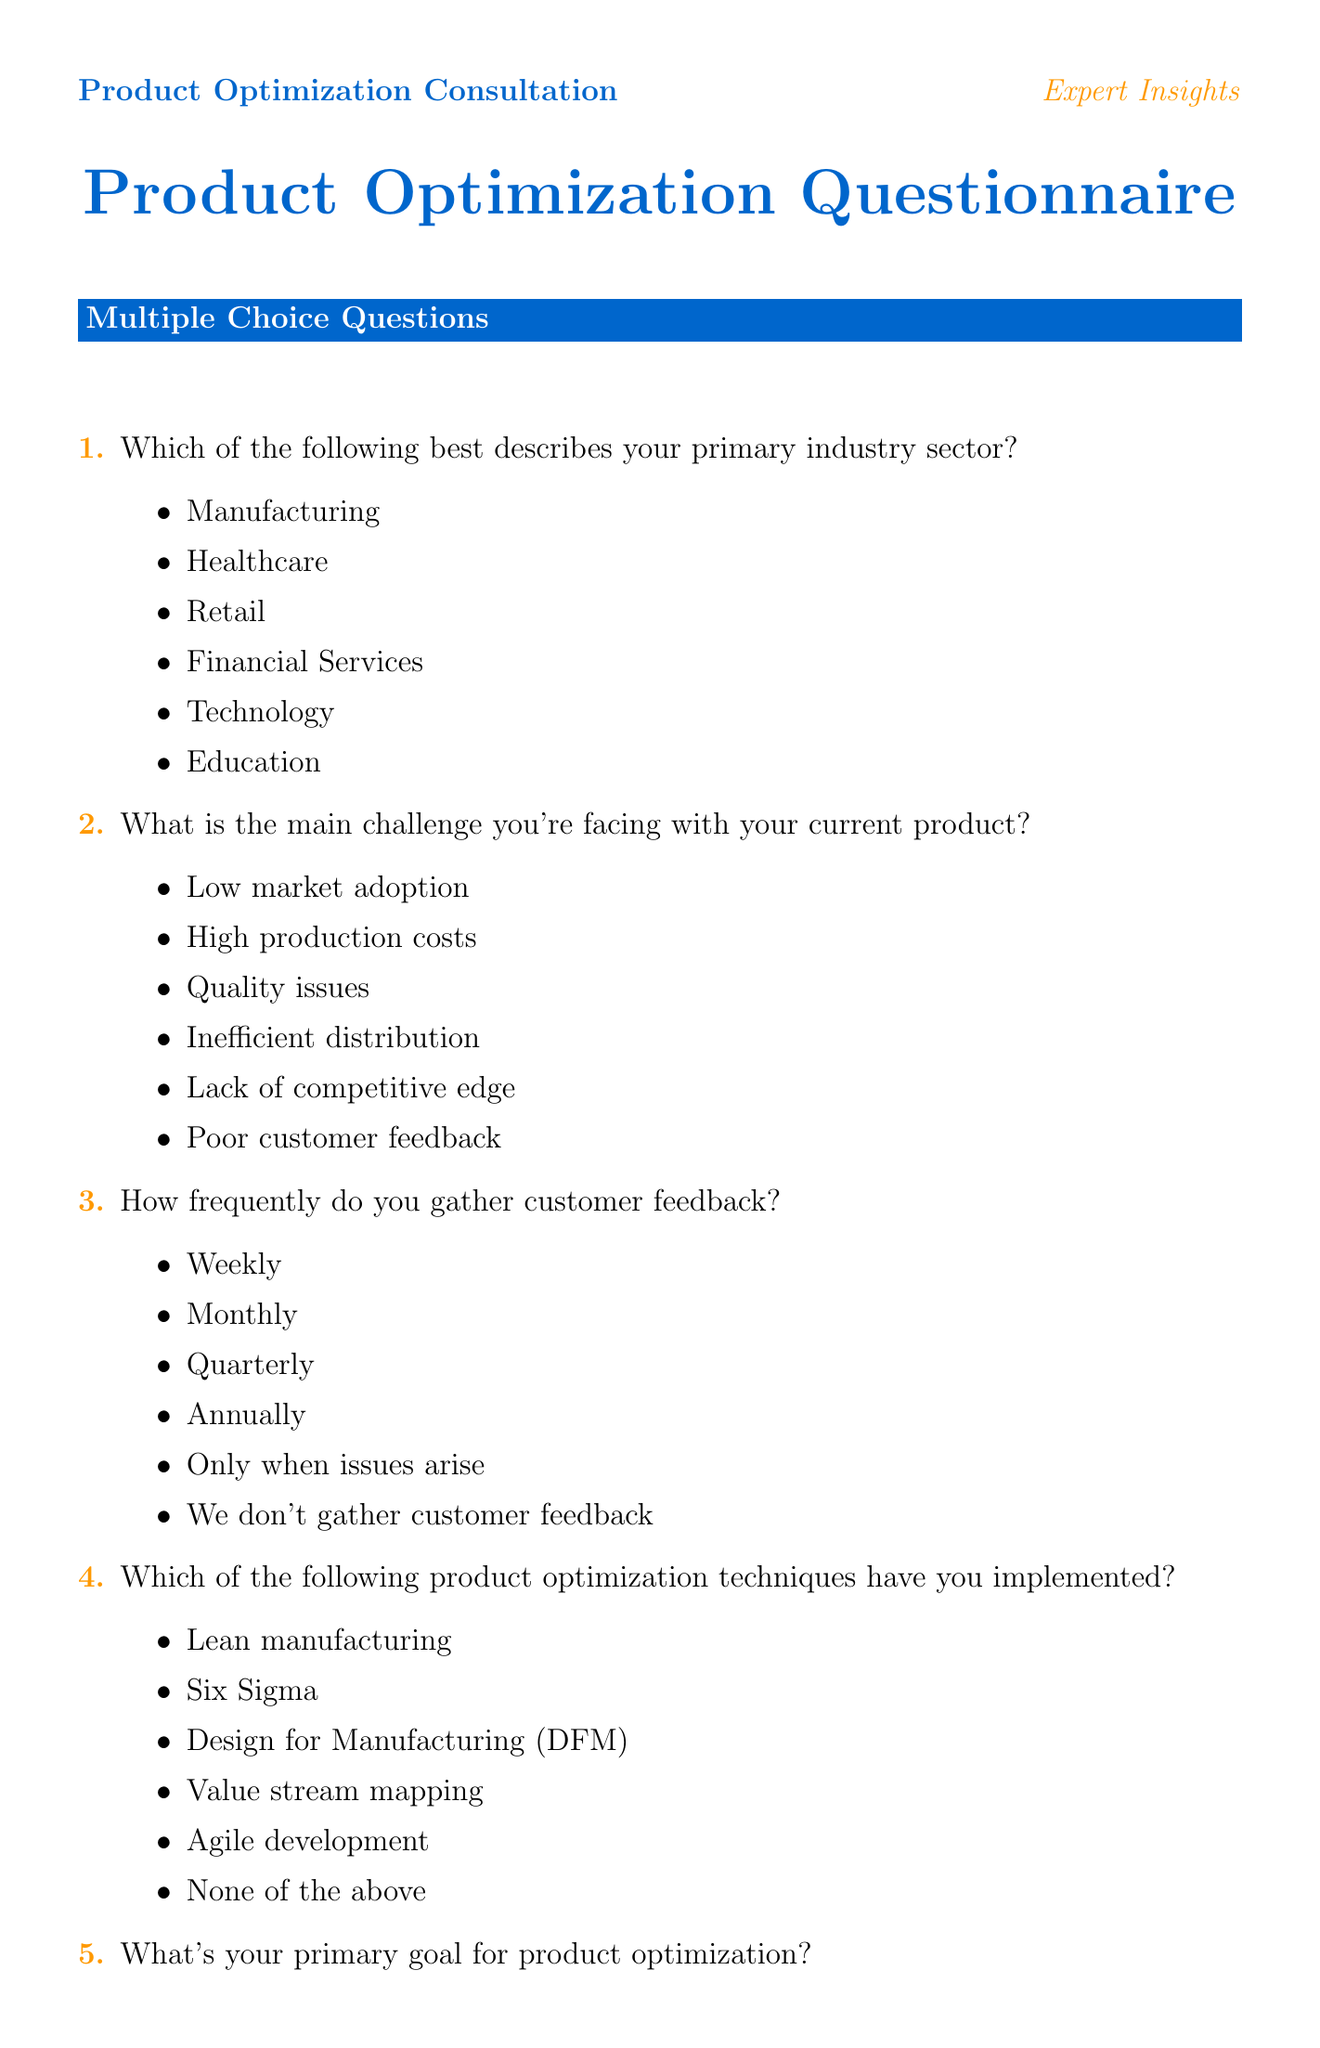Which industry sector is included in the options? The document lists various industry sectors in the multiple-choice questions, including Manufacturing, Healthcare, Retail, Financial Services, Technology, and Education.
Answer: Manufacturing, Healthcare, Retail, Financial Services, Technology, Education What is the main challenge with the product? The document specifies multiple challenges in the second question, such as Low market adoption, High production costs, Quality issues, and others.
Answer: Low market adoption How often is customer feedback gathered according to the options? The document presents various frequencies for gathering customer feedback, including Weekly, Monthly, and Quarterly among others.
Answer: Weekly What is the scoring scale used for the prioritization matrix? The document defines a scoring scale for evaluating options in the prioritization matrix, ranging from Very Low to Very High.
Answer: 1 - Very Low, 2 - Low, 3 - Medium, 4 - High, 5 - Very High What is one aspect of additional considerations mentioned in the document? The document provides several aspects under additional considerations, such as Regulatory Compliance, Sustainability, Scalability, and Integration with Existing Systems.
Answer: Regulatory Compliance What industry-specific recommendation is given for Healthcare? The document includes specific recommendations for different industries, including the Healthcare sector, emphasizing interoperability with electronic health record systems.
Answer: Focus on interoperability to ensure seamless integration with various electronic health record (EHR) systems Which product optimization technique is listed as an option? The document includes various product optimization techniques in the questionnaire, including Lean manufacturing, Six Sigma, and Agile development.
Answer: Lean manufacturing What is the primary goal for product optimization according to the options? The document outlines several primary goals for product optimization, such as Reduce costs, Improve quality, Increase market share, and more.
Answer: Reduce costs 